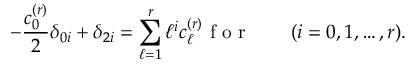<formula> <loc_0><loc_0><loc_500><loc_500>- \frac { c _ { 0 } ^ { ( r ) } } { 2 } \delta _ { 0 i } + \delta _ { 2 i } = \sum _ { \ell = 1 } ^ { r } \ell ^ { i } c _ { \ell } ^ { ( r ) } f o r \quad ( i = 0 , 1 , \dots , r ) .</formula> 